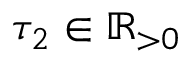Convert formula to latex. <formula><loc_0><loc_0><loc_500><loc_500>\tau _ { 2 } \in \mathbb { R } _ { > 0 }</formula> 